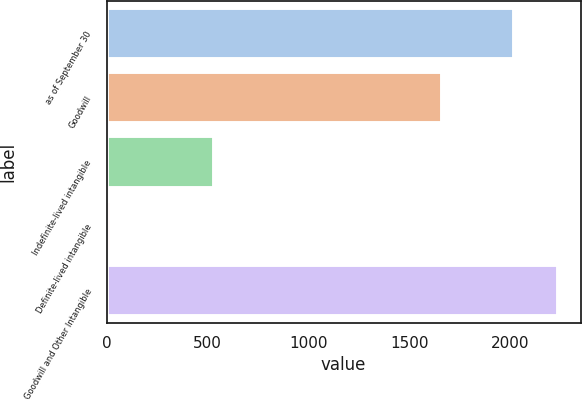Convert chart to OTSL. <chart><loc_0><loc_0><loc_500><loc_500><bar_chart><fcel>as of September 30<fcel>Goodwill<fcel>Indefinite-lived intangible<fcel>Definite-lived intangible<fcel>Goodwill and Other Intangible<nl><fcel>2016<fcel>1661.2<fcel>530.9<fcel>19.2<fcel>2235.21<nl></chart> 